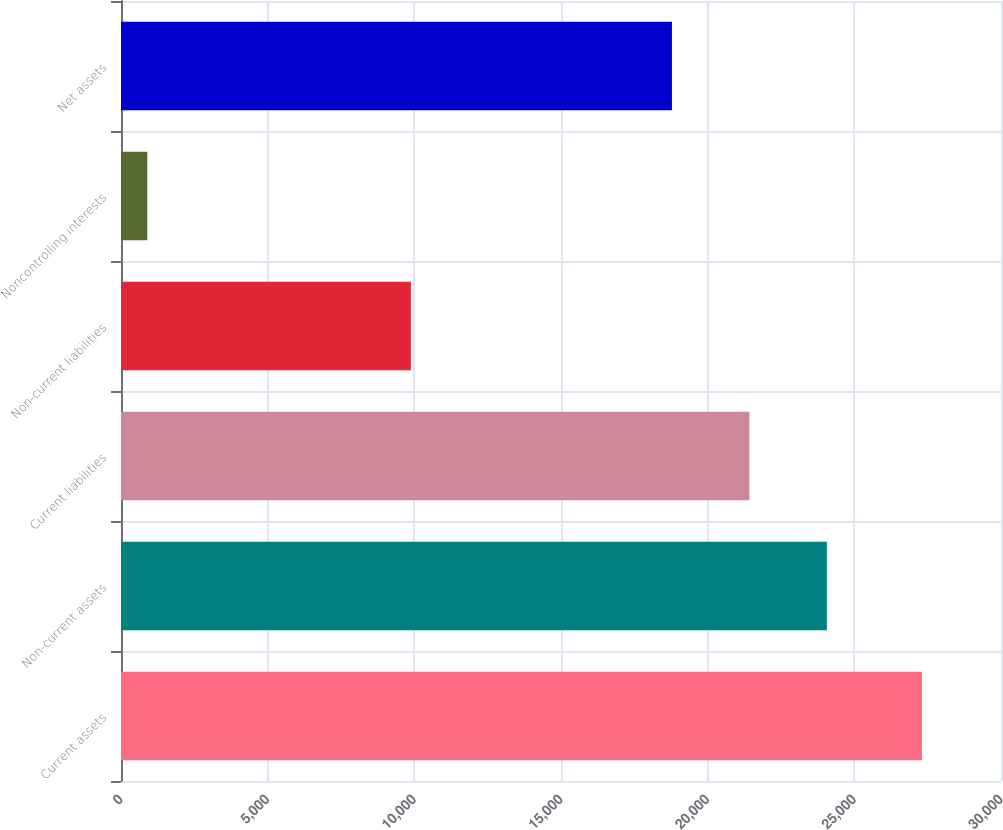<chart> <loc_0><loc_0><loc_500><loc_500><bar_chart><fcel>Current assets<fcel>Non-current assets<fcel>Current liabilities<fcel>Non-current liabilities<fcel>Noncontrolling interests<fcel>Net assets<nl><fcel>27307<fcel>24064<fcel>21423<fcel>9882<fcel>897<fcel>18782<nl></chart> 